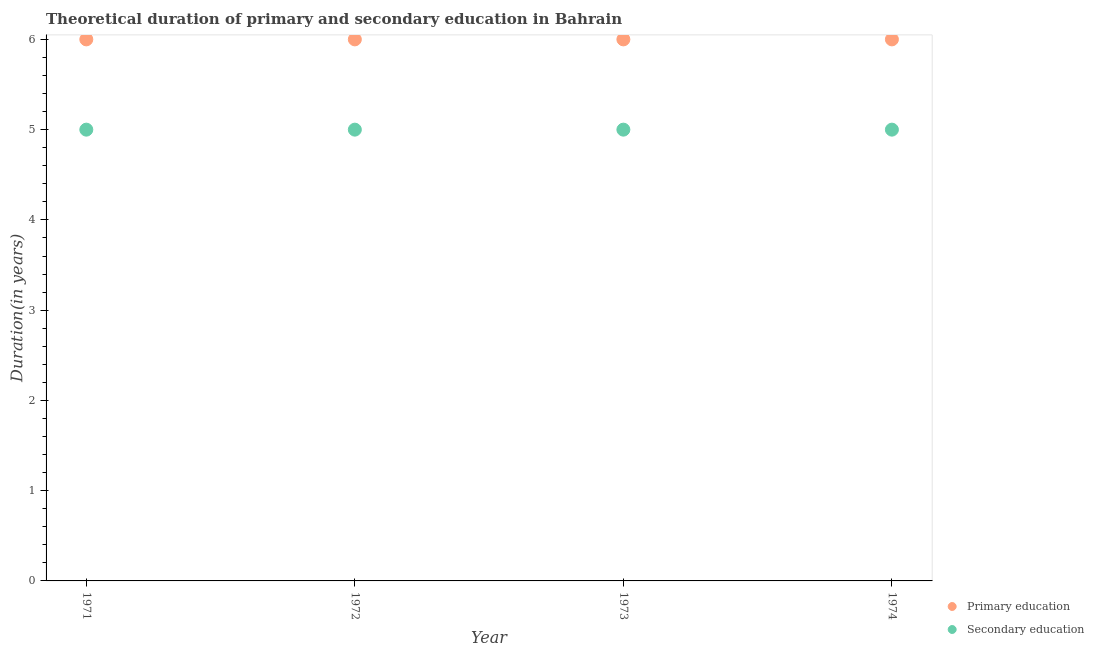How many different coloured dotlines are there?
Your answer should be very brief. 2. What is the duration of primary education in 1973?
Your response must be concise. 6. Across all years, what is the maximum duration of primary education?
Offer a very short reply. 6. Across all years, what is the minimum duration of primary education?
Ensure brevity in your answer.  6. In which year was the duration of primary education maximum?
Give a very brief answer. 1971. In which year was the duration of primary education minimum?
Keep it short and to the point. 1971. What is the total duration of primary education in the graph?
Your response must be concise. 24. What is the difference between the duration of primary education in 1971 and that in 1973?
Provide a short and direct response. 0. What is the difference between the duration of secondary education in 1972 and the duration of primary education in 1973?
Offer a terse response. -1. What is the average duration of secondary education per year?
Make the answer very short. 5. In the year 1972, what is the difference between the duration of secondary education and duration of primary education?
Make the answer very short. -1. What is the ratio of the duration of primary education in 1973 to that in 1974?
Provide a short and direct response. 1. Is the duration of primary education in 1972 less than that in 1974?
Your answer should be very brief. No. Is the difference between the duration of primary education in 1971 and 1972 greater than the difference between the duration of secondary education in 1971 and 1972?
Keep it short and to the point. No. What is the difference between the highest and the lowest duration of primary education?
Provide a succinct answer. 0. In how many years, is the duration of primary education greater than the average duration of primary education taken over all years?
Ensure brevity in your answer.  0. Is the sum of the duration of secondary education in 1971 and 1974 greater than the maximum duration of primary education across all years?
Offer a very short reply. Yes. How many years are there in the graph?
Ensure brevity in your answer.  4. What is the difference between two consecutive major ticks on the Y-axis?
Provide a succinct answer. 1. Are the values on the major ticks of Y-axis written in scientific E-notation?
Offer a very short reply. No. Does the graph contain any zero values?
Ensure brevity in your answer.  No. Does the graph contain grids?
Make the answer very short. No. Where does the legend appear in the graph?
Keep it short and to the point. Bottom right. What is the title of the graph?
Ensure brevity in your answer.  Theoretical duration of primary and secondary education in Bahrain. Does "Secondary" appear as one of the legend labels in the graph?
Keep it short and to the point. No. What is the label or title of the X-axis?
Your answer should be very brief. Year. What is the label or title of the Y-axis?
Provide a short and direct response. Duration(in years). What is the Duration(in years) in Primary education in 1971?
Your response must be concise. 6. What is the Duration(in years) in Secondary education in 1971?
Make the answer very short. 5. What is the Duration(in years) of Primary education in 1972?
Give a very brief answer. 6. What is the Duration(in years) of Primary education in 1973?
Your answer should be very brief. 6. What is the Duration(in years) of Secondary education in 1974?
Offer a terse response. 5. Across all years, what is the maximum Duration(in years) of Primary education?
Make the answer very short. 6. Across all years, what is the minimum Duration(in years) in Primary education?
Provide a succinct answer. 6. What is the total Duration(in years) in Primary education in the graph?
Offer a very short reply. 24. What is the total Duration(in years) of Secondary education in the graph?
Your answer should be very brief. 20. What is the difference between the Duration(in years) in Secondary education in 1971 and that in 1974?
Offer a very short reply. 0. What is the difference between the Duration(in years) in Primary education in 1972 and that in 1973?
Your response must be concise. 0. What is the difference between the Duration(in years) in Secondary education in 1972 and that in 1973?
Offer a very short reply. 0. What is the difference between the Duration(in years) of Primary education in 1972 and that in 1974?
Your response must be concise. 0. What is the difference between the Duration(in years) of Primary education in 1973 and that in 1974?
Your answer should be compact. 0. What is the difference between the Duration(in years) of Secondary education in 1973 and that in 1974?
Provide a succinct answer. 0. What is the difference between the Duration(in years) in Primary education in 1971 and the Duration(in years) in Secondary education in 1973?
Your response must be concise. 1. What is the difference between the Duration(in years) of Primary education in 1971 and the Duration(in years) of Secondary education in 1974?
Give a very brief answer. 1. What is the difference between the Duration(in years) of Primary education in 1972 and the Duration(in years) of Secondary education in 1973?
Ensure brevity in your answer.  1. What is the difference between the Duration(in years) of Primary education in 1972 and the Duration(in years) of Secondary education in 1974?
Offer a terse response. 1. What is the difference between the Duration(in years) in Primary education in 1973 and the Duration(in years) in Secondary education in 1974?
Your answer should be very brief. 1. What is the ratio of the Duration(in years) of Primary education in 1971 to that in 1973?
Give a very brief answer. 1. What is the ratio of the Duration(in years) in Secondary education in 1971 to that in 1973?
Keep it short and to the point. 1. What is the ratio of the Duration(in years) of Primary education in 1971 to that in 1974?
Give a very brief answer. 1. What is the ratio of the Duration(in years) in Secondary education in 1971 to that in 1974?
Your answer should be very brief. 1. What is the ratio of the Duration(in years) of Primary education in 1972 to that in 1973?
Ensure brevity in your answer.  1. What is the ratio of the Duration(in years) of Secondary education in 1972 to that in 1973?
Ensure brevity in your answer.  1. What is the ratio of the Duration(in years) in Secondary education in 1972 to that in 1974?
Provide a short and direct response. 1. What is the ratio of the Duration(in years) in Primary education in 1973 to that in 1974?
Offer a very short reply. 1. What is the difference between the highest and the second highest Duration(in years) in Primary education?
Give a very brief answer. 0. What is the difference between the highest and the second highest Duration(in years) in Secondary education?
Your answer should be very brief. 0. What is the difference between the highest and the lowest Duration(in years) of Primary education?
Ensure brevity in your answer.  0. 